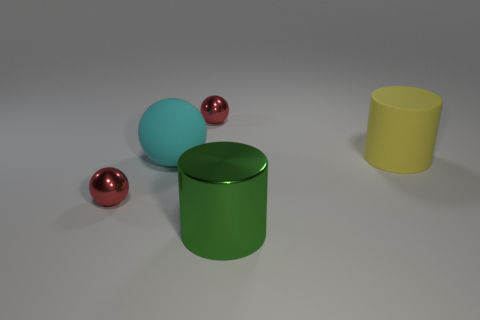How many other objects are there of the same color as the large rubber cylinder?
Your answer should be compact. 0. What shape is the matte thing left of the shiny cylinder?
Give a very brief answer. Sphere. Is the big green thing made of the same material as the big cyan sphere?
Offer a very short reply. No. Is there anything else that is the same size as the cyan object?
Offer a very short reply. Yes. There is a green cylinder; what number of big objects are right of it?
Your response must be concise. 1. The big yellow thing that is to the right of the green cylinder that is to the left of the yellow matte object is what shape?
Provide a succinct answer. Cylinder. Is there any other thing that has the same shape as the cyan object?
Ensure brevity in your answer.  Yes. Is the number of large objects on the right side of the big rubber sphere greater than the number of large gray cubes?
Provide a succinct answer. Yes. What number of big green cylinders are in front of the red sphere that is behind the big cyan matte object?
Provide a short and direct response. 1. The large matte thing on the right side of the tiny metal ball that is behind the object that is on the right side of the large green object is what shape?
Provide a short and direct response. Cylinder. 